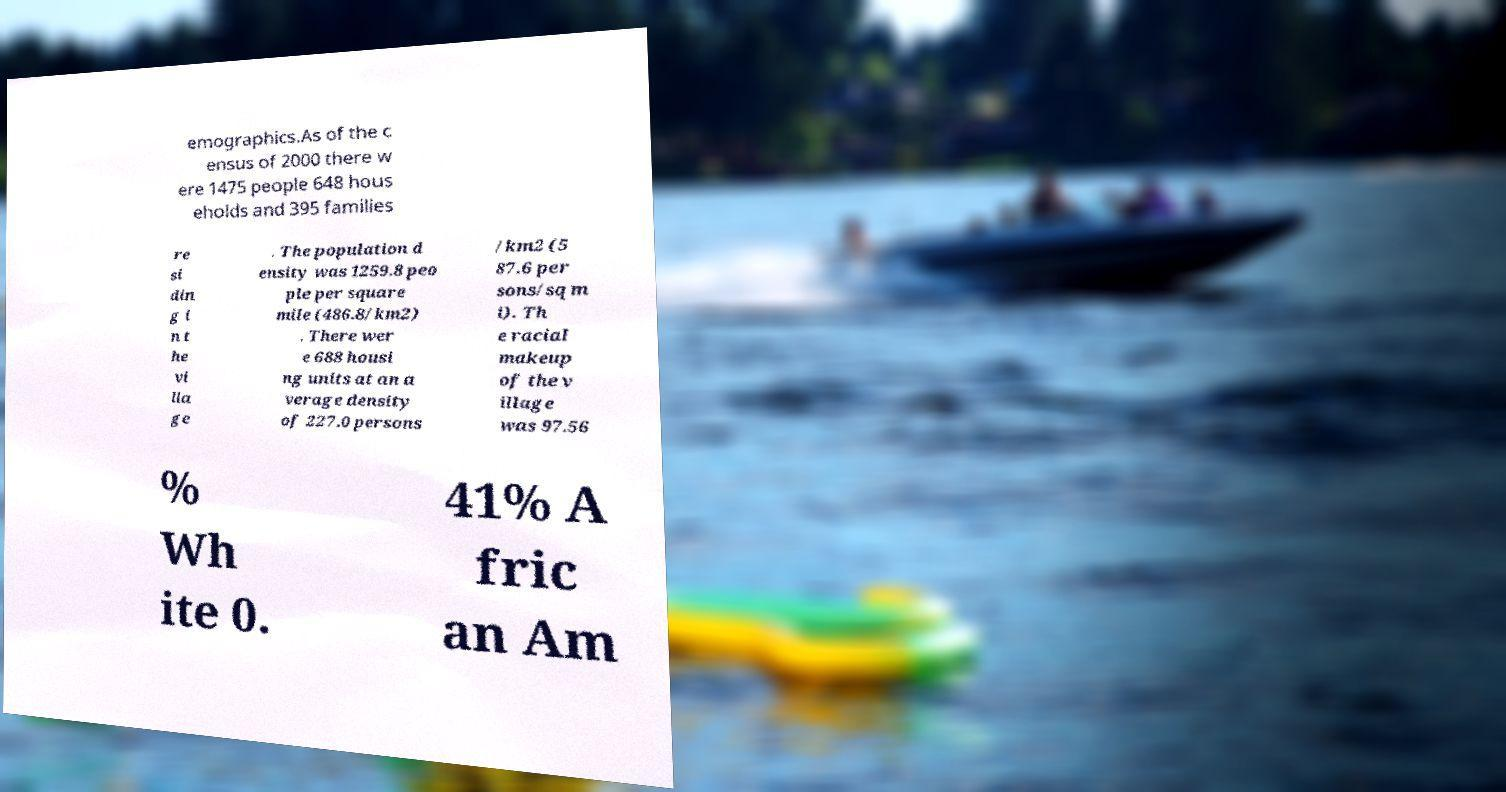Could you extract and type out the text from this image? emographics.As of the c ensus of 2000 there w ere 1475 people 648 hous eholds and 395 families re si din g i n t he vi lla ge . The population d ensity was 1259.8 peo ple per square mile (486.8/km2) . There wer e 688 housi ng units at an a verage density of 227.0 persons /km2 (5 87.6 per sons/sq m i). Th e racial makeup of the v illage was 97.56 % Wh ite 0. 41% A fric an Am 